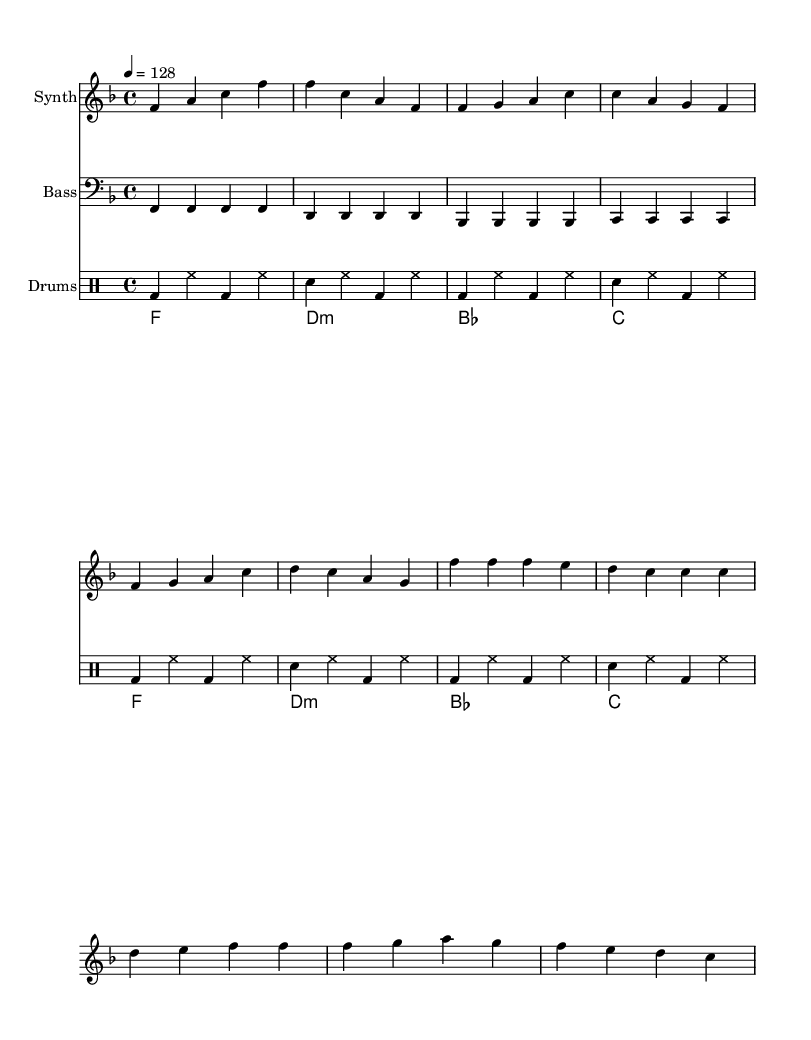What is the key signature of this music? The key signature shows one flat (B flat), which indicates that the music is written in F major.
Answer: F major What is the time signature of this music? The time signature is indicated at the beginning of the staff, showing four beats per measure, so it is 4/4.
Answer: 4/4 What is the tempo marking in this music? The tempo marking specifies the speed of the music, which is set at 128 beats per minute.
Answer: 128 How many bars are in the verse section? By analyzing the verse section, we count four measures that contain musical phrases ending in clear bar lines.
Answer: 4 What are the lyrics for the chorus? The chorus lyrics are taken directly from the lyrics section, which states "Hustle and flow, that's how we grow, Manage your time, watch your income grow."
Answer: "Hustle and flow, that's how we grow, Manage your time, watch your income grow." What type of musical instruments are used in this piece? The sheet music indicates three different staves, which are for Synth, Bass, and Drums, showing their respective instrumental parts.
Answer: Synth, Bass, Drums What style of music does this piece represent? This piece features characteristics such as an upbeat tempo and motivational lyrics, which are typical of the House genre.
Answer: House 